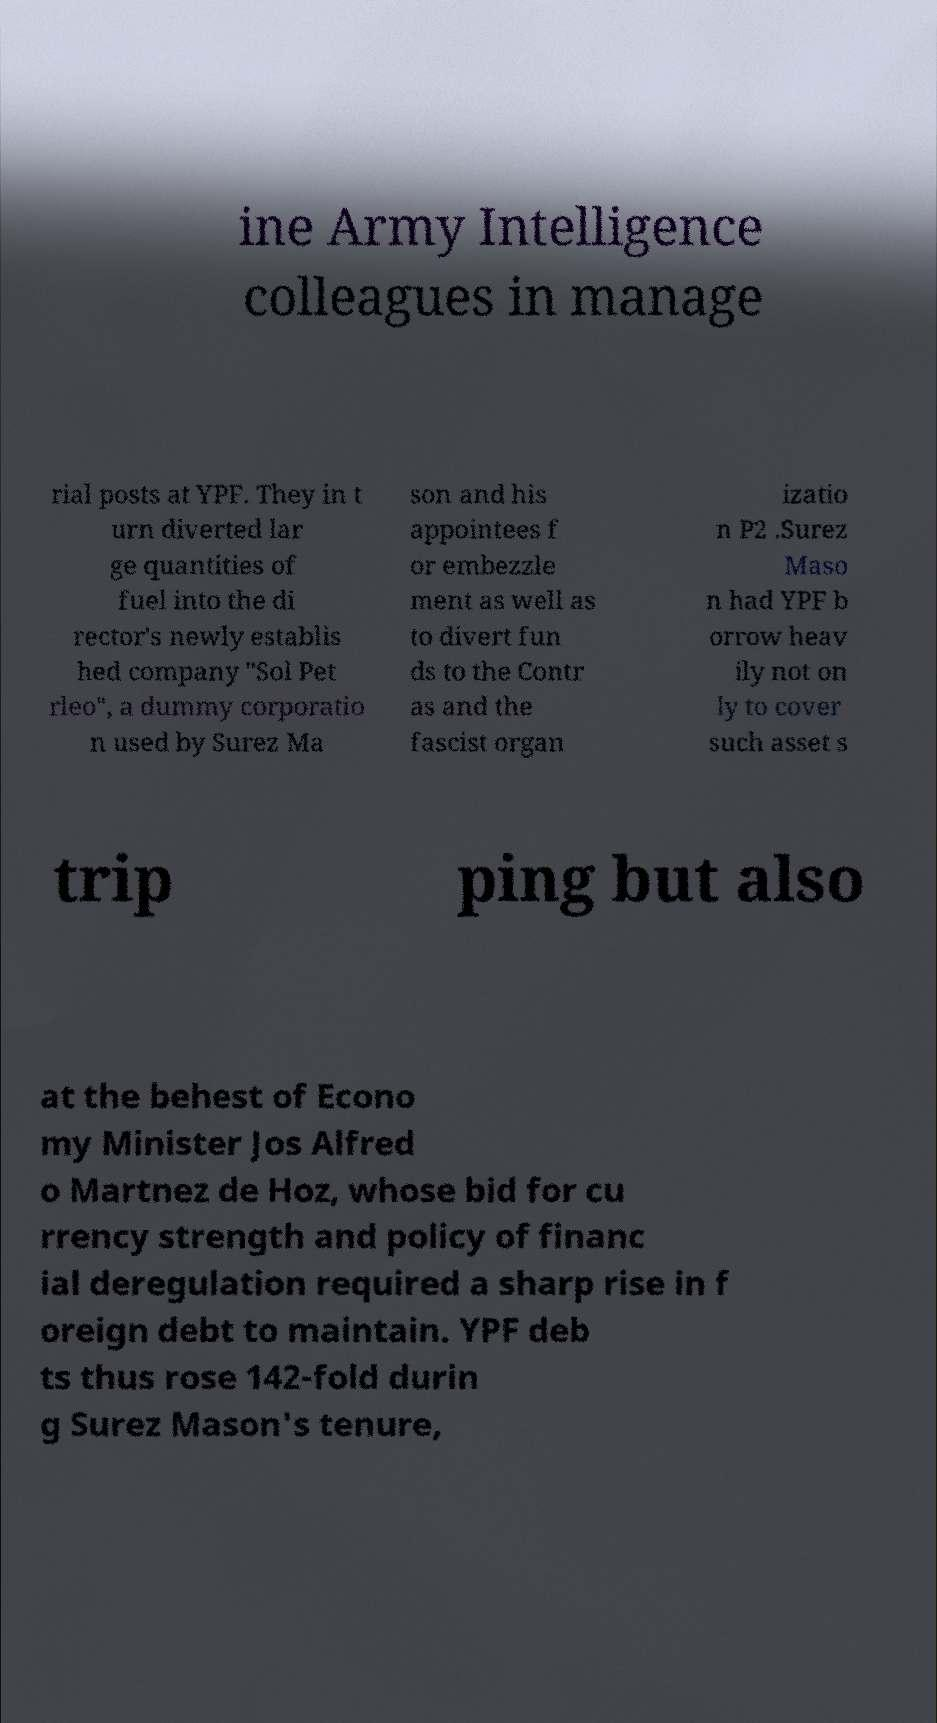Could you assist in decoding the text presented in this image and type it out clearly? ine Army Intelligence colleagues in manage rial posts at YPF. They in t urn diverted lar ge quantities of fuel into the di rector's newly establis hed company "Sol Pet rleo", a dummy corporatio n used by Surez Ma son and his appointees f or embezzle ment as well as to divert fun ds to the Contr as and the fascist organ izatio n P2 .Surez Maso n had YPF b orrow heav ily not on ly to cover such asset s trip ping but also at the behest of Econo my Minister Jos Alfred o Martnez de Hoz, whose bid for cu rrency strength and policy of financ ial deregulation required a sharp rise in f oreign debt to maintain. YPF deb ts thus rose 142-fold durin g Surez Mason's tenure, 